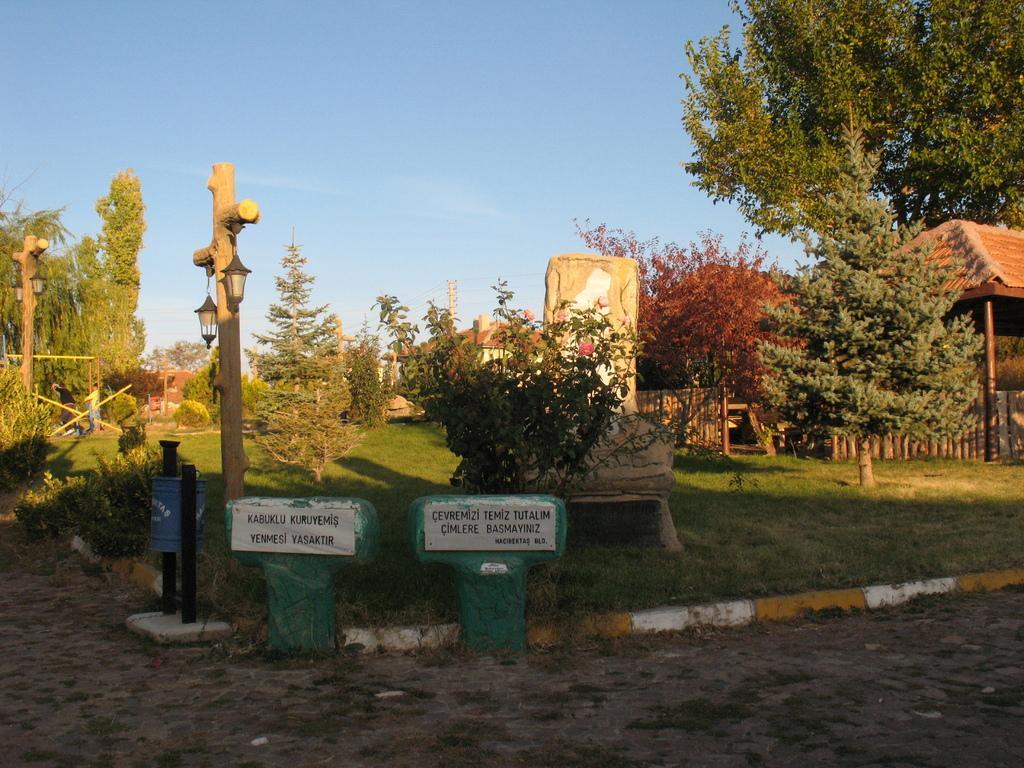How would you summarize this image in a sentence or two? There are two sign boards present at the bottom of this image, and there are some trees present on a grassy land as we can see in the middle of this image, and there is a sky at the top of this image. 